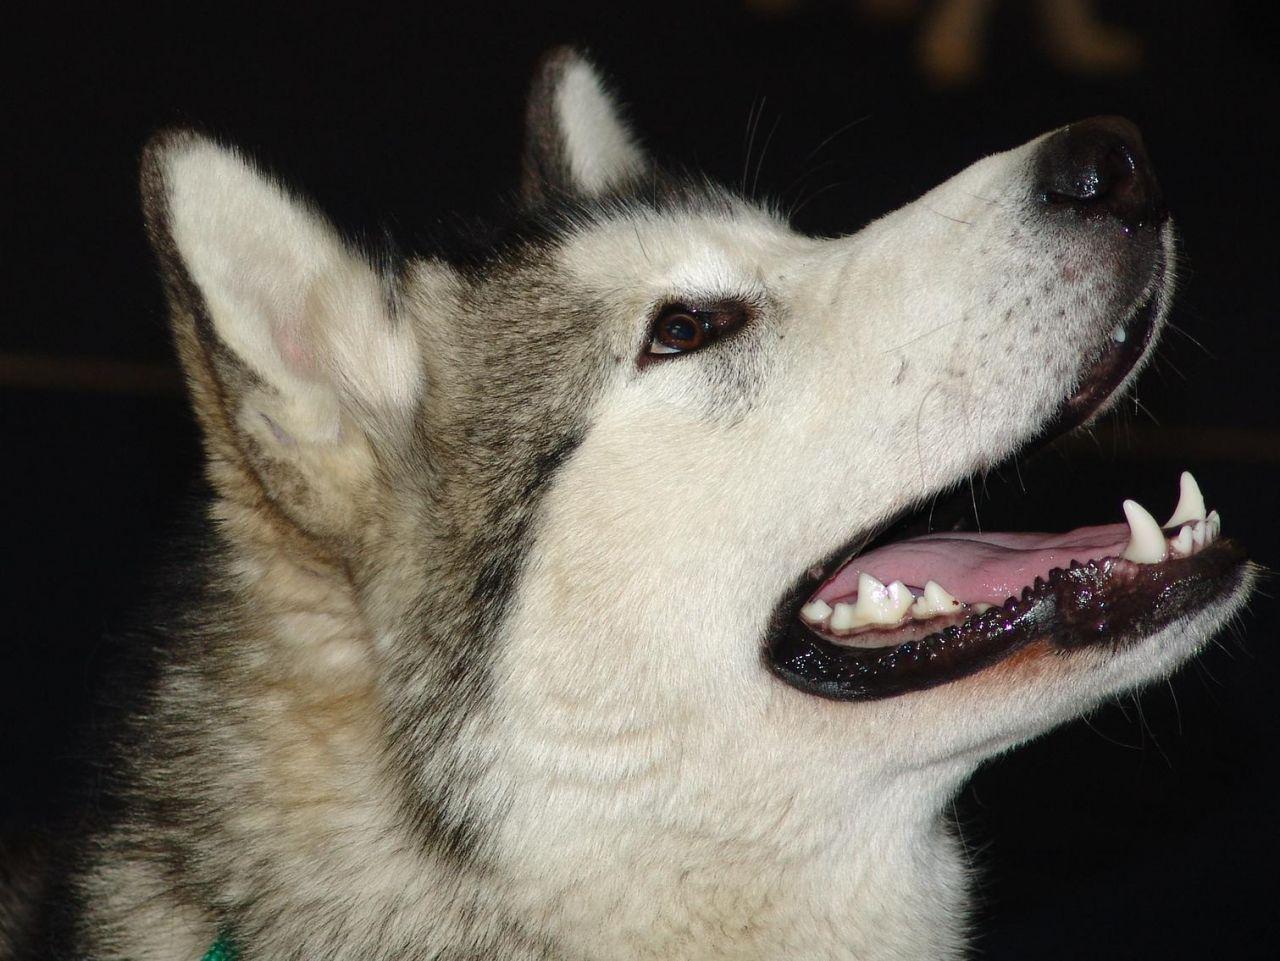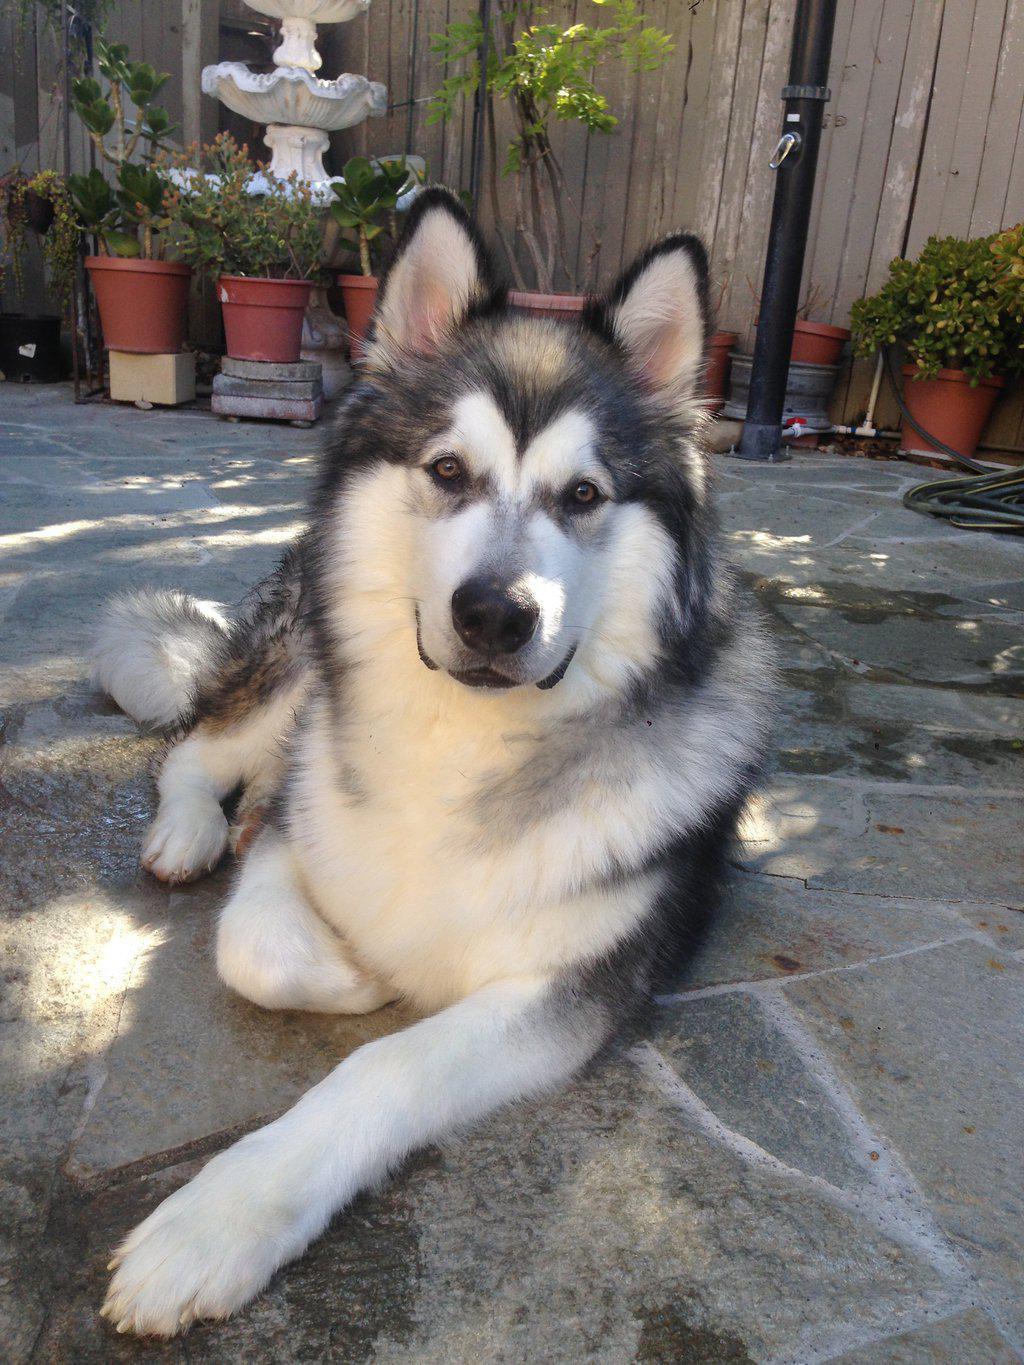The first image is the image on the left, the second image is the image on the right. For the images shown, is this caption "The left image features one dog, which is facing rightward, and the right image features a reclining dog with its head upright and body facing forward." true? Answer yes or no. Yes. The first image is the image on the left, the second image is the image on the right. Considering the images on both sides, is "There is at least one human in the image pair." valid? Answer yes or no. No. 